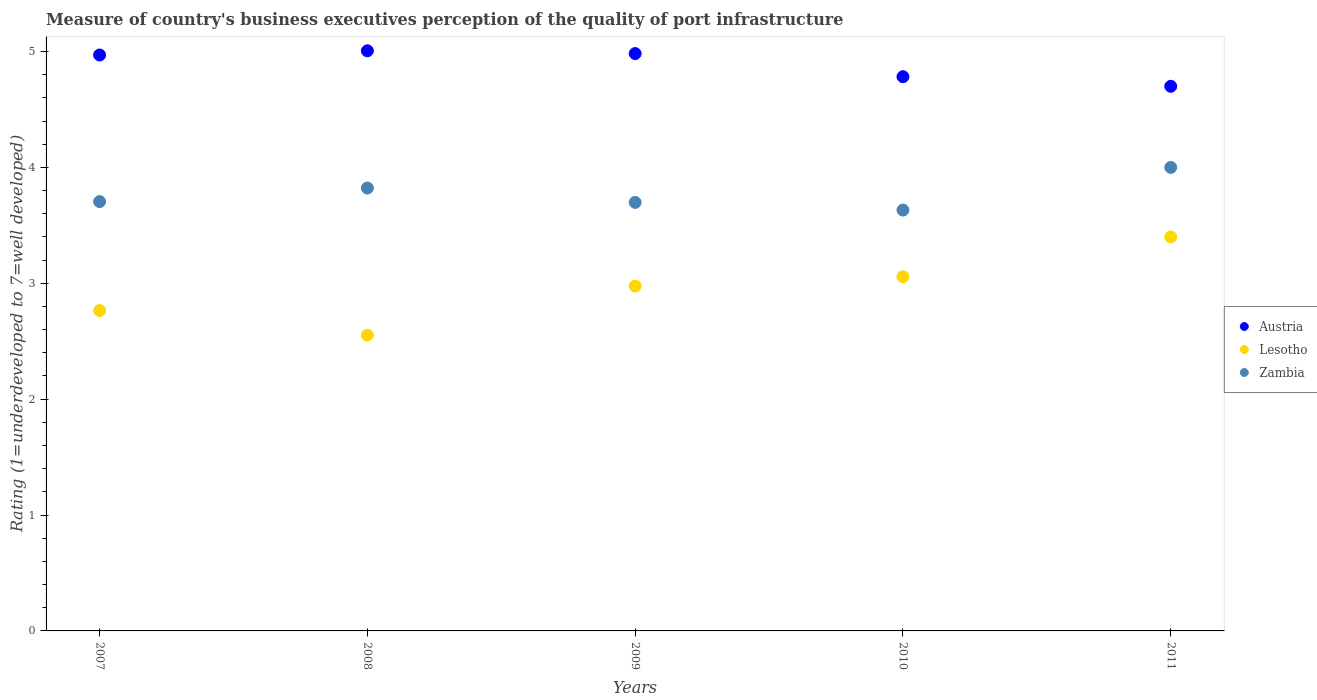What is the ratings of the quality of port infrastructure in Austria in 2009?
Keep it short and to the point. 4.98. Across all years, what is the minimum ratings of the quality of port infrastructure in Austria?
Ensure brevity in your answer.  4.7. What is the total ratings of the quality of port infrastructure in Zambia in the graph?
Your answer should be very brief. 18.86. What is the difference between the ratings of the quality of port infrastructure in Lesotho in 2007 and that in 2008?
Your answer should be compact. 0.21. What is the difference between the ratings of the quality of port infrastructure in Zambia in 2009 and the ratings of the quality of port infrastructure in Lesotho in 2008?
Provide a succinct answer. 1.15. What is the average ratings of the quality of port infrastructure in Lesotho per year?
Offer a very short reply. 2.95. In the year 2007, what is the difference between the ratings of the quality of port infrastructure in Austria and ratings of the quality of port infrastructure in Zambia?
Give a very brief answer. 1.27. In how many years, is the ratings of the quality of port infrastructure in Zambia greater than 4.6?
Offer a very short reply. 0. What is the ratio of the ratings of the quality of port infrastructure in Lesotho in 2008 to that in 2011?
Keep it short and to the point. 0.75. Is the ratings of the quality of port infrastructure in Austria in 2007 less than that in 2008?
Offer a very short reply. Yes. What is the difference between the highest and the second highest ratings of the quality of port infrastructure in Austria?
Give a very brief answer. 0.02. What is the difference between the highest and the lowest ratings of the quality of port infrastructure in Zambia?
Keep it short and to the point. 0.37. In how many years, is the ratings of the quality of port infrastructure in Austria greater than the average ratings of the quality of port infrastructure in Austria taken over all years?
Provide a short and direct response. 3. Is the sum of the ratings of the quality of port infrastructure in Zambia in 2008 and 2009 greater than the maximum ratings of the quality of port infrastructure in Lesotho across all years?
Your response must be concise. Yes. Is it the case that in every year, the sum of the ratings of the quality of port infrastructure in Lesotho and ratings of the quality of port infrastructure in Austria  is greater than the ratings of the quality of port infrastructure in Zambia?
Your answer should be compact. Yes. Is the ratings of the quality of port infrastructure in Austria strictly greater than the ratings of the quality of port infrastructure in Zambia over the years?
Make the answer very short. Yes. How many dotlines are there?
Give a very brief answer. 3. Are the values on the major ticks of Y-axis written in scientific E-notation?
Make the answer very short. No. Where does the legend appear in the graph?
Give a very brief answer. Center right. How are the legend labels stacked?
Keep it short and to the point. Vertical. What is the title of the graph?
Make the answer very short. Measure of country's business executives perception of the quality of port infrastructure. Does "Other small states" appear as one of the legend labels in the graph?
Your answer should be compact. No. What is the label or title of the Y-axis?
Your response must be concise. Rating (1=underdeveloped to 7=well developed). What is the Rating (1=underdeveloped to 7=well developed) of Austria in 2007?
Provide a succinct answer. 4.97. What is the Rating (1=underdeveloped to 7=well developed) in Lesotho in 2007?
Ensure brevity in your answer.  2.76. What is the Rating (1=underdeveloped to 7=well developed) in Zambia in 2007?
Ensure brevity in your answer.  3.7. What is the Rating (1=underdeveloped to 7=well developed) of Austria in 2008?
Your answer should be very brief. 5.01. What is the Rating (1=underdeveloped to 7=well developed) in Lesotho in 2008?
Provide a succinct answer. 2.55. What is the Rating (1=underdeveloped to 7=well developed) of Zambia in 2008?
Ensure brevity in your answer.  3.82. What is the Rating (1=underdeveloped to 7=well developed) in Austria in 2009?
Provide a short and direct response. 4.98. What is the Rating (1=underdeveloped to 7=well developed) in Lesotho in 2009?
Provide a short and direct response. 2.98. What is the Rating (1=underdeveloped to 7=well developed) of Zambia in 2009?
Provide a succinct answer. 3.7. What is the Rating (1=underdeveloped to 7=well developed) in Austria in 2010?
Offer a very short reply. 4.78. What is the Rating (1=underdeveloped to 7=well developed) in Lesotho in 2010?
Your response must be concise. 3.06. What is the Rating (1=underdeveloped to 7=well developed) of Zambia in 2010?
Your answer should be compact. 3.63. What is the Rating (1=underdeveloped to 7=well developed) in Austria in 2011?
Provide a short and direct response. 4.7. Across all years, what is the maximum Rating (1=underdeveloped to 7=well developed) of Austria?
Your answer should be very brief. 5.01. Across all years, what is the minimum Rating (1=underdeveloped to 7=well developed) in Lesotho?
Give a very brief answer. 2.55. Across all years, what is the minimum Rating (1=underdeveloped to 7=well developed) of Zambia?
Provide a succinct answer. 3.63. What is the total Rating (1=underdeveloped to 7=well developed) in Austria in the graph?
Offer a terse response. 24.44. What is the total Rating (1=underdeveloped to 7=well developed) of Lesotho in the graph?
Your response must be concise. 14.75. What is the total Rating (1=underdeveloped to 7=well developed) of Zambia in the graph?
Your response must be concise. 18.86. What is the difference between the Rating (1=underdeveloped to 7=well developed) of Austria in 2007 and that in 2008?
Give a very brief answer. -0.04. What is the difference between the Rating (1=underdeveloped to 7=well developed) of Lesotho in 2007 and that in 2008?
Your answer should be compact. 0.21. What is the difference between the Rating (1=underdeveloped to 7=well developed) in Zambia in 2007 and that in 2008?
Give a very brief answer. -0.12. What is the difference between the Rating (1=underdeveloped to 7=well developed) in Austria in 2007 and that in 2009?
Your answer should be very brief. -0.01. What is the difference between the Rating (1=underdeveloped to 7=well developed) in Lesotho in 2007 and that in 2009?
Ensure brevity in your answer.  -0.21. What is the difference between the Rating (1=underdeveloped to 7=well developed) of Zambia in 2007 and that in 2009?
Your response must be concise. 0.01. What is the difference between the Rating (1=underdeveloped to 7=well developed) of Austria in 2007 and that in 2010?
Make the answer very short. 0.19. What is the difference between the Rating (1=underdeveloped to 7=well developed) in Lesotho in 2007 and that in 2010?
Your answer should be very brief. -0.29. What is the difference between the Rating (1=underdeveloped to 7=well developed) in Zambia in 2007 and that in 2010?
Your answer should be compact. 0.07. What is the difference between the Rating (1=underdeveloped to 7=well developed) in Austria in 2007 and that in 2011?
Make the answer very short. 0.27. What is the difference between the Rating (1=underdeveloped to 7=well developed) of Lesotho in 2007 and that in 2011?
Ensure brevity in your answer.  -0.64. What is the difference between the Rating (1=underdeveloped to 7=well developed) of Zambia in 2007 and that in 2011?
Make the answer very short. -0.3. What is the difference between the Rating (1=underdeveloped to 7=well developed) of Austria in 2008 and that in 2009?
Your response must be concise. 0.02. What is the difference between the Rating (1=underdeveloped to 7=well developed) in Lesotho in 2008 and that in 2009?
Ensure brevity in your answer.  -0.42. What is the difference between the Rating (1=underdeveloped to 7=well developed) of Zambia in 2008 and that in 2009?
Offer a very short reply. 0.12. What is the difference between the Rating (1=underdeveloped to 7=well developed) of Austria in 2008 and that in 2010?
Your response must be concise. 0.22. What is the difference between the Rating (1=underdeveloped to 7=well developed) of Lesotho in 2008 and that in 2010?
Make the answer very short. -0.5. What is the difference between the Rating (1=underdeveloped to 7=well developed) of Zambia in 2008 and that in 2010?
Your answer should be compact. 0.19. What is the difference between the Rating (1=underdeveloped to 7=well developed) in Austria in 2008 and that in 2011?
Provide a short and direct response. 0.31. What is the difference between the Rating (1=underdeveloped to 7=well developed) in Lesotho in 2008 and that in 2011?
Ensure brevity in your answer.  -0.85. What is the difference between the Rating (1=underdeveloped to 7=well developed) in Zambia in 2008 and that in 2011?
Offer a very short reply. -0.18. What is the difference between the Rating (1=underdeveloped to 7=well developed) in Austria in 2009 and that in 2010?
Your answer should be compact. 0.2. What is the difference between the Rating (1=underdeveloped to 7=well developed) in Lesotho in 2009 and that in 2010?
Your answer should be compact. -0.08. What is the difference between the Rating (1=underdeveloped to 7=well developed) of Zambia in 2009 and that in 2010?
Provide a short and direct response. 0.07. What is the difference between the Rating (1=underdeveloped to 7=well developed) in Austria in 2009 and that in 2011?
Offer a very short reply. 0.28. What is the difference between the Rating (1=underdeveloped to 7=well developed) of Lesotho in 2009 and that in 2011?
Provide a succinct answer. -0.42. What is the difference between the Rating (1=underdeveloped to 7=well developed) of Zambia in 2009 and that in 2011?
Offer a very short reply. -0.3. What is the difference between the Rating (1=underdeveloped to 7=well developed) of Austria in 2010 and that in 2011?
Offer a terse response. 0.08. What is the difference between the Rating (1=underdeveloped to 7=well developed) of Lesotho in 2010 and that in 2011?
Give a very brief answer. -0.34. What is the difference between the Rating (1=underdeveloped to 7=well developed) of Zambia in 2010 and that in 2011?
Make the answer very short. -0.37. What is the difference between the Rating (1=underdeveloped to 7=well developed) in Austria in 2007 and the Rating (1=underdeveloped to 7=well developed) in Lesotho in 2008?
Make the answer very short. 2.42. What is the difference between the Rating (1=underdeveloped to 7=well developed) in Austria in 2007 and the Rating (1=underdeveloped to 7=well developed) in Zambia in 2008?
Give a very brief answer. 1.15. What is the difference between the Rating (1=underdeveloped to 7=well developed) in Lesotho in 2007 and the Rating (1=underdeveloped to 7=well developed) in Zambia in 2008?
Provide a short and direct response. -1.06. What is the difference between the Rating (1=underdeveloped to 7=well developed) in Austria in 2007 and the Rating (1=underdeveloped to 7=well developed) in Lesotho in 2009?
Make the answer very short. 1.99. What is the difference between the Rating (1=underdeveloped to 7=well developed) of Austria in 2007 and the Rating (1=underdeveloped to 7=well developed) of Zambia in 2009?
Offer a terse response. 1.27. What is the difference between the Rating (1=underdeveloped to 7=well developed) in Lesotho in 2007 and the Rating (1=underdeveloped to 7=well developed) in Zambia in 2009?
Provide a succinct answer. -0.93. What is the difference between the Rating (1=underdeveloped to 7=well developed) of Austria in 2007 and the Rating (1=underdeveloped to 7=well developed) of Lesotho in 2010?
Keep it short and to the point. 1.91. What is the difference between the Rating (1=underdeveloped to 7=well developed) of Austria in 2007 and the Rating (1=underdeveloped to 7=well developed) of Zambia in 2010?
Offer a terse response. 1.34. What is the difference between the Rating (1=underdeveloped to 7=well developed) in Lesotho in 2007 and the Rating (1=underdeveloped to 7=well developed) in Zambia in 2010?
Your answer should be compact. -0.87. What is the difference between the Rating (1=underdeveloped to 7=well developed) of Austria in 2007 and the Rating (1=underdeveloped to 7=well developed) of Lesotho in 2011?
Your answer should be compact. 1.57. What is the difference between the Rating (1=underdeveloped to 7=well developed) in Austria in 2007 and the Rating (1=underdeveloped to 7=well developed) in Zambia in 2011?
Your answer should be compact. 0.97. What is the difference between the Rating (1=underdeveloped to 7=well developed) in Lesotho in 2007 and the Rating (1=underdeveloped to 7=well developed) in Zambia in 2011?
Your answer should be very brief. -1.24. What is the difference between the Rating (1=underdeveloped to 7=well developed) of Austria in 2008 and the Rating (1=underdeveloped to 7=well developed) of Lesotho in 2009?
Provide a succinct answer. 2.03. What is the difference between the Rating (1=underdeveloped to 7=well developed) of Austria in 2008 and the Rating (1=underdeveloped to 7=well developed) of Zambia in 2009?
Ensure brevity in your answer.  1.31. What is the difference between the Rating (1=underdeveloped to 7=well developed) in Lesotho in 2008 and the Rating (1=underdeveloped to 7=well developed) in Zambia in 2009?
Offer a terse response. -1.15. What is the difference between the Rating (1=underdeveloped to 7=well developed) in Austria in 2008 and the Rating (1=underdeveloped to 7=well developed) in Lesotho in 2010?
Give a very brief answer. 1.95. What is the difference between the Rating (1=underdeveloped to 7=well developed) in Austria in 2008 and the Rating (1=underdeveloped to 7=well developed) in Zambia in 2010?
Your answer should be compact. 1.37. What is the difference between the Rating (1=underdeveloped to 7=well developed) of Lesotho in 2008 and the Rating (1=underdeveloped to 7=well developed) of Zambia in 2010?
Keep it short and to the point. -1.08. What is the difference between the Rating (1=underdeveloped to 7=well developed) of Austria in 2008 and the Rating (1=underdeveloped to 7=well developed) of Lesotho in 2011?
Keep it short and to the point. 1.61. What is the difference between the Rating (1=underdeveloped to 7=well developed) of Austria in 2008 and the Rating (1=underdeveloped to 7=well developed) of Zambia in 2011?
Offer a very short reply. 1.01. What is the difference between the Rating (1=underdeveloped to 7=well developed) of Lesotho in 2008 and the Rating (1=underdeveloped to 7=well developed) of Zambia in 2011?
Ensure brevity in your answer.  -1.45. What is the difference between the Rating (1=underdeveloped to 7=well developed) of Austria in 2009 and the Rating (1=underdeveloped to 7=well developed) of Lesotho in 2010?
Your response must be concise. 1.93. What is the difference between the Rating (1=underdeveloped to 7=well developed) of Austria in 2009 and the Rating (1=underdeveloped to 7=well developed) of Zambia in 2010?
Your response must be concise. 1.35. What is the difference between the Rating (1=underdeveloped to 7=well developed) in Lesotho in 2009 and the Rating (1=underdeveloped to 7=well developed) in Zambia in 2010?
Your answer should be very brief. -0.66. What is the difference between the Rating (1=underdeveloped to 7=well developed) in Austria in 2009 and the Rating (1=underdeveloped to 7=well developed) in Lesotho in 2011?
Provide a succinct answer. 1.58. What is the difference between the Rating (1=underdeveloped to 7=well developed) in Austria in 2009 and the Rating (1=underdeveloped to 7=well developed) in Zambia in 2011?
Provide a short and direct response. 0.98. What is the difference between the Rating (1=underdeveloped to 7=well developed) of Lesotho in 2009 and the Rating (1=underdeveloped to 7=well developed) of Zambia in 2011?
Offer a terse response. -1.02. What is the difference between the Rating (1=underdeveloped to 7=well developed) of Austria in 2010 and the Rating (1=underdeveloped to 7=well developed) of Lesotho in 2011?
Make the answer very short. 1.38. What is the difference between the Rating (1=underdeveloped to 7=well developed) of Austria in 2010 and the Rating (1=underdeveloped to 7=well developed) of Zambia in 2011?
Offer a terse response. 0.78. What is the difference between the Rating (1=underdeveloped to 7=well developed) in Lesotho in 2010 and the Rating (1=underdeveloped to 7=well developed) in Zambia in 2011?
Give a very brief answer. -0.94. What is the average Rating (1=underdeveloped to 7=well developed) in Austria per year?
Ensure brevity in your answer.  4.89. What is the average Rating (1=underdeveloped to 7=well developed) of Lesotho per year?
Provide a succinct answer. 2.95. What is the average Rating (1=underdeveloped to 7=well developed) of Zambia per year?
Give a very brief answer. 3.77. In the year 2007, what is the difference between the Rating (1=underdeveloped to 7=well developed) in Austria and Rating (1=underdeveloped to 7=well developed) in Lesotho?
Provide a short and direct response. 2.21. In the year 2007, what is the difference between the Rating (1=underdeveloped to 7=well developed) in Austria and Rating (1=underdeveloped to 7=well developed) in Zambia?
Your response must be concise. 1.27. In the year 2007, what is the difference between the Rating (1=underdeveloped to 7=well developed) in Lesotho and Rating (1=underdeveloped to 7=well developed) in Zambia?
Your response must be concise. -0.94. In the year 2008, what is the difference between the Rating (1=underdeveloped to 7=well developed) in Austria and Rating (1=underdeveloped to 7=well developed) in Lesotho?
Provide a short and direct response. 2.45. In the year 2008, what is the difference between the Rating (1=underdeveloped to 7=well developed) in Austria and Rating (1=underdeveloped to 7=well developed) in Zambia?
Provide a succinct answer. 1.18. In the year 2008, what is the difference between the Rating (1=underdeveloped to 7=well developed) in Lesotho and Rating (1=underdeveloped to 7=well developed) in Zambia?
Provide a succinct answer. -1.27. In the year 2009, what is the difference between the Rating (1=underdeveloped to 7=well developed) in Austria and Rating (1=underdeveloped to 7=well developed) in Lesotho?
Your answer should be compact. 2.01. In the year 2009, what is the difference between the Rating (1=underdeveloped to 7=well developed) of Austria and Rating (1=underdeveloped to 7=well developed) of Zambia?
Keep it short and to the point. 1.28. In the year 2009, what is the difference between the Rating (1=underdeveloped to 7=well developed) of Lesotho and Rating (1=underdeveloped to 7=well developed) of Zambia?
Give a very brief answer. -0.72. In the year 2010, what is the difference between the Rating (1=underdeveloped to 7=well developed) in Austria and Rating (1=underdeveloped to 7=well developed) in Lesotho?
Make the answer very short. 1.73. In the year 2010, what is the difference between the Rating (1=underdeveloped to 7=well developed) of Austria and Rating (1=underdeveloped to 7=well developed) of Zambia?
Provide a short and direct response. 1.15. In the year 2010, what is the difference between the Rating (1=underdeveloped to 7=well developed) of Lesotho and Rating (1=underdeveloped to 7=well developed) of Zambia?
Ensure brevity in your answer.  -0.58. What is the ratio of the Rating (1=underdeveloped to 7=well developed) of Austria in 2007 to that in 2008?
Keep it short and to the point. 0.99. What is the ratio of the Rating (1=underdeveloped to 7=well developed) in Lesotho in 2007 to that in 2008?
Give a very brief answer. 1.08. What is the ratio of the Rating (1=underdeveloped to 7=well developed) of Zambia in 2007 to that in 2008?
Your response must be concise. 0.97. What is the ratio of the Rating (1=underdeveloped to 7=well developed) of Austria in 2007 to that in 2009?
Ensure brevity in your answer.  1. What is the ratio of the Rating (1=underdeveloped to 7=well developed) in Lesotho in 2007 to that in 2009?
Provide a succinct answer. 0.93. What is the ratio of the Rating (1=underdeveloped to 7=well developed) in Austria in 2007 to that in 2010?
Offer a very short reply. 1.04. What is the ratio of the Rating (1=underdeveloped to 7=well developed) in Lesotho in 2007 to that in 2010?
Offer a terse response. 0.9. What is the ratio of the Rating (1=underdeveloped to 7=well developed) in Zambia in 2007 to that in 2010?
Offer a terse response. 1.02. What is the ratio of the Rating (1=underdeveloped to 7=well developed) in Austria in 2007 to that in 2011?
Provide a succinct answer. 1.06. What is the ratio of the Rating (1=underdeveloped to 7=well developed) in Lesotho in 2007 to that in 2011?
Provide a succinct answer. 0.81. What is the ratio of the Rating (1=underdeveloped to 7=well developed) of Zambia in 2007 to that in 2011?
Keep it short and to the point. 0.93. What is the ratio of the Rating (1=underdeveloped to 7=well developed) of Austria in 2008 to that in 2009?
Keep it short and to the point. 1. What is the ratio of the Rating (1=underdeveloped to 7=well developed) of Lesotho in 2008 to that in 2009?
Your response must be concise. 0.86. What is the ratio of the Rating (1=underdeveloped to 7=well developed) of Zambia in 2008 to that in 2009?
Your answer should be compact. 1.03. What is the ratio of the Rating (1=underdeveloped to 7=well developed) of Austria in 2008 to that in 2010?
Make the answer very short. 1.05. What is the ratio of the Rating (1=underdeveloped to 7=well developed) of Lesotho in 2008 to that in 2010?
Keep it short and to the point. 0.84. What is the ratio of the Rating (1=underdeveloped to 7=well developed) in Zambia in 2008 to that in 2010?
Offer a very short reply. 1.05. What is the ratio of the Rating (1=underdeveloped to 7=well developed) in Austria in 2008 to that in 2011?
Ensure brevity in your answer.  1.07. What is the ratio of the Rating (1=underdeveloped to 7=well developed) in Lesotho in 2008 to that in 2011?
Your answer should be very brief. 0.75. What is the ratio of the Rating (1=underdeveloped to 7=well developed) of Zambia in 2008 to that in 2011?
Your answer should be compact. 0.96. What is the ratio of the Rating (1=underdeveloped to 7=well developed) in Austria in 2009 to that in 2010?
Your response must be concise. 1.04. What is the ratio of the Rating (1=underdeveloped to 7=well developed) of Lesotho in 2009 to that in 2010?
Your response must be concise. 0.97. What is the ratio of the Rating (1=underdeveloped to 7=well developed) of Zambia in 2009 to that in 2010?
Your response must be concise. 1.02. What is the ratio of the Rating (1=underdeveloped to 7=well developed) in Austria in 2009 to that in 2011?
Offer a very short reply. 1.06. What is the ratio of the Rating (1=underdeveloped to 7=well developed) in Lesotho in 2009 to that in 2011?
Your response must be concise. 0.88. What is the ratio of the Rating (1=underdeveloped to 7=well developed) of Zambia in 2009 to that in 2011?
Your response must be concise. 0.92. What is the ratio of the Rating (1=underdeveloped to 7=well developed) in Austria in 2010 to that in 2011?
Your answer should be compact. 1.02. What is the ratio of the Rating (1=underdeveloped to 7=well developed) of Lesotho in 2010 to that in 2011?
Keep it short and to the point. 0.9. What is the ratio of the Rating (1=underdeveloped to 7=well developed) in Zambia in 2010 to that in 2011?
Your answer should be compact. 0.91. What is the difference between the highest and the second highest Rating (1=underdeveloped to 7=well developed) of Austria?
Keep it short and to the point. 0.02. What is the difference between the highest and the second highest Rating (1=underdeveloped to 7=well developed) in Lesotho?
Offer a very short reply. 0.34. What is the difference between the highest and the second highest Rating (1=underdeveloped to 7=well developed) in Zambia?
Give a very brief answer. 0.18. What is the difference between the highest and the lowest Rating (1=underdeveloped to 7=well developed) of Austria?
Provide a succinct answer. 0.31. What is the difference between the highest and the lowest Rating (1=underdeveloped to 7=well developed) of Lesotho?
Your response must be concise. 0.85. What is the difference between the highest and the lowest Rating (1=underdeveloped to 7=well developed) of Zambia?
Your answer should be compact. 0.37. 